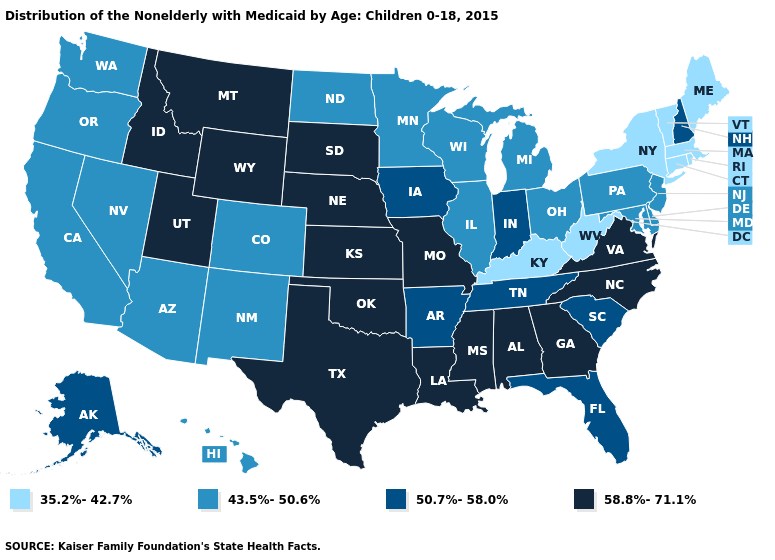Is the legend a continuous bar?
Give a very brief answer. No. Name the states that have a value in the range 58.8%-71.1%?
Short answer required. Alabama, Georgia, Idaho, Kansas, Louisiana, Mississippi, Missouri, Montana, Nebraska, North Carolina, Oklahoma, South Dakota, Texas, Utah, Virginia, Wyoming. Name the states that have a value in the range 43.5%-50.6%?
Write a very short answer. Arizona, California, Colorado, Delaware, Hawaii, Illinois, Maryland, Michigan, Minnesota, Nevada, New Jersey, New Mexico, North Dakota, Ohio, Oregon, Pennsylvania, Washington, Wisconsin. Name the states that have a value in the range 50.7%-58.0%?
Answer briefly. Alaska, Arkansas, Florida, Indiana, Iowa, New Hampshire, South Carolina, Tennessee. Name the states that have a value in the range 43.5%-50.6%?
Keep it brief. Arizona, California, Colorado, Delaware, Hawaii, Illinois, Maryland, Michigan, Minnesota, Nevada, New Jersey, New Mexico, North Dakota, Ohio, Oregon, Pennsylvania, Washington, Wisconsin. Among the states that border North Dakota , does Montana have the highest value?
Concise answer only. Yes. What is the lowest value in the South?
Be succinct. 35.2%-42.7%. What is the value of Kansas?
Answer briefly. 58.8%-71.1%. Does Minnesota have a higher value than Nebraska?
Short answer required. No. Which states have the lowest value in the West?
Concise answer only. Arizona, California, Colorado, Hawaii, Nevada, New Mexico, Oregon, Washington. Name the states that have a value in the range 43.5%-50.6%?
Be succinct. Arizona, California, Colorado, Delaware, Hawaii, Illinois, Maryland, Michigan, Minnesota, Nevada, New Jersey, New Mexico, North Dakota, Ohio, Oregon, Pennsylvania, Washington, Wisconsin. Name the states that have a value in the range 43.5%-50.6%?
Concise answer only. Arizona, California, Colorado, Delaware, Hawaii, Illinois, Maryland, Michigan, Minnesota, Nevada, New Jersey, New Mexico, North Dakota, Ohio, Oregon, Pennsylvania, Washington, Wisconsin. Does Idaho have the highest value in the West?
Give a very brief answer. Yes. What is the lowest value in the West?
Concise answer only. 43.5%-50.6%. 